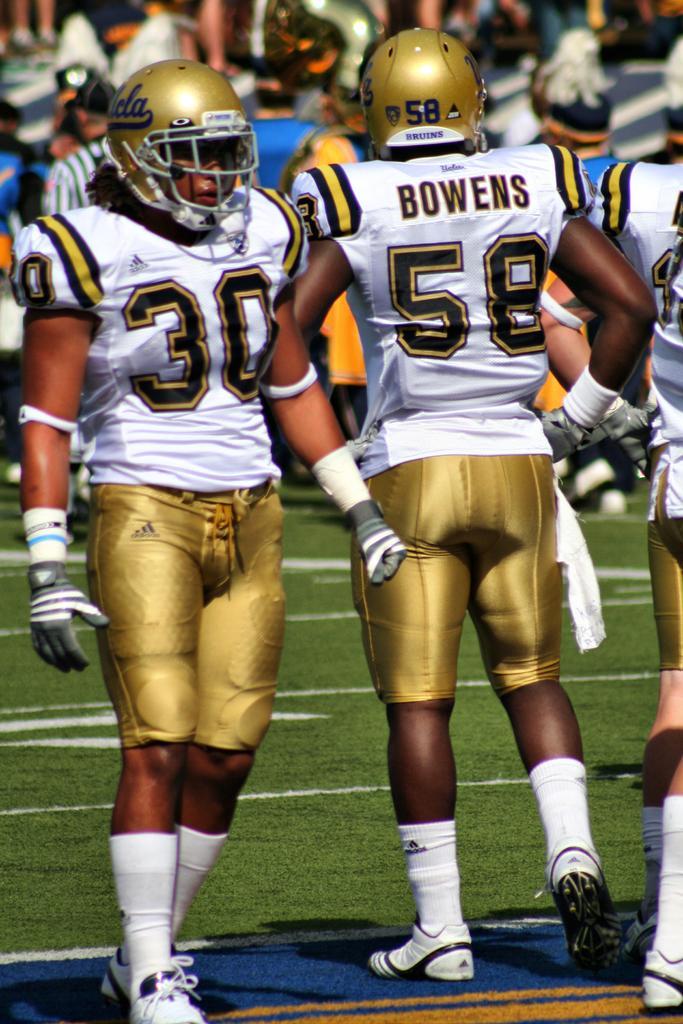In one or two sentences, can you explain what this image depicts? In this image there is ground at the bottom. There are people in the foreground. And there are people in the background. 